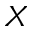Convert formula to latex. <formula><loc_0><loc_0><loc_500><loc_500>X</formula> 